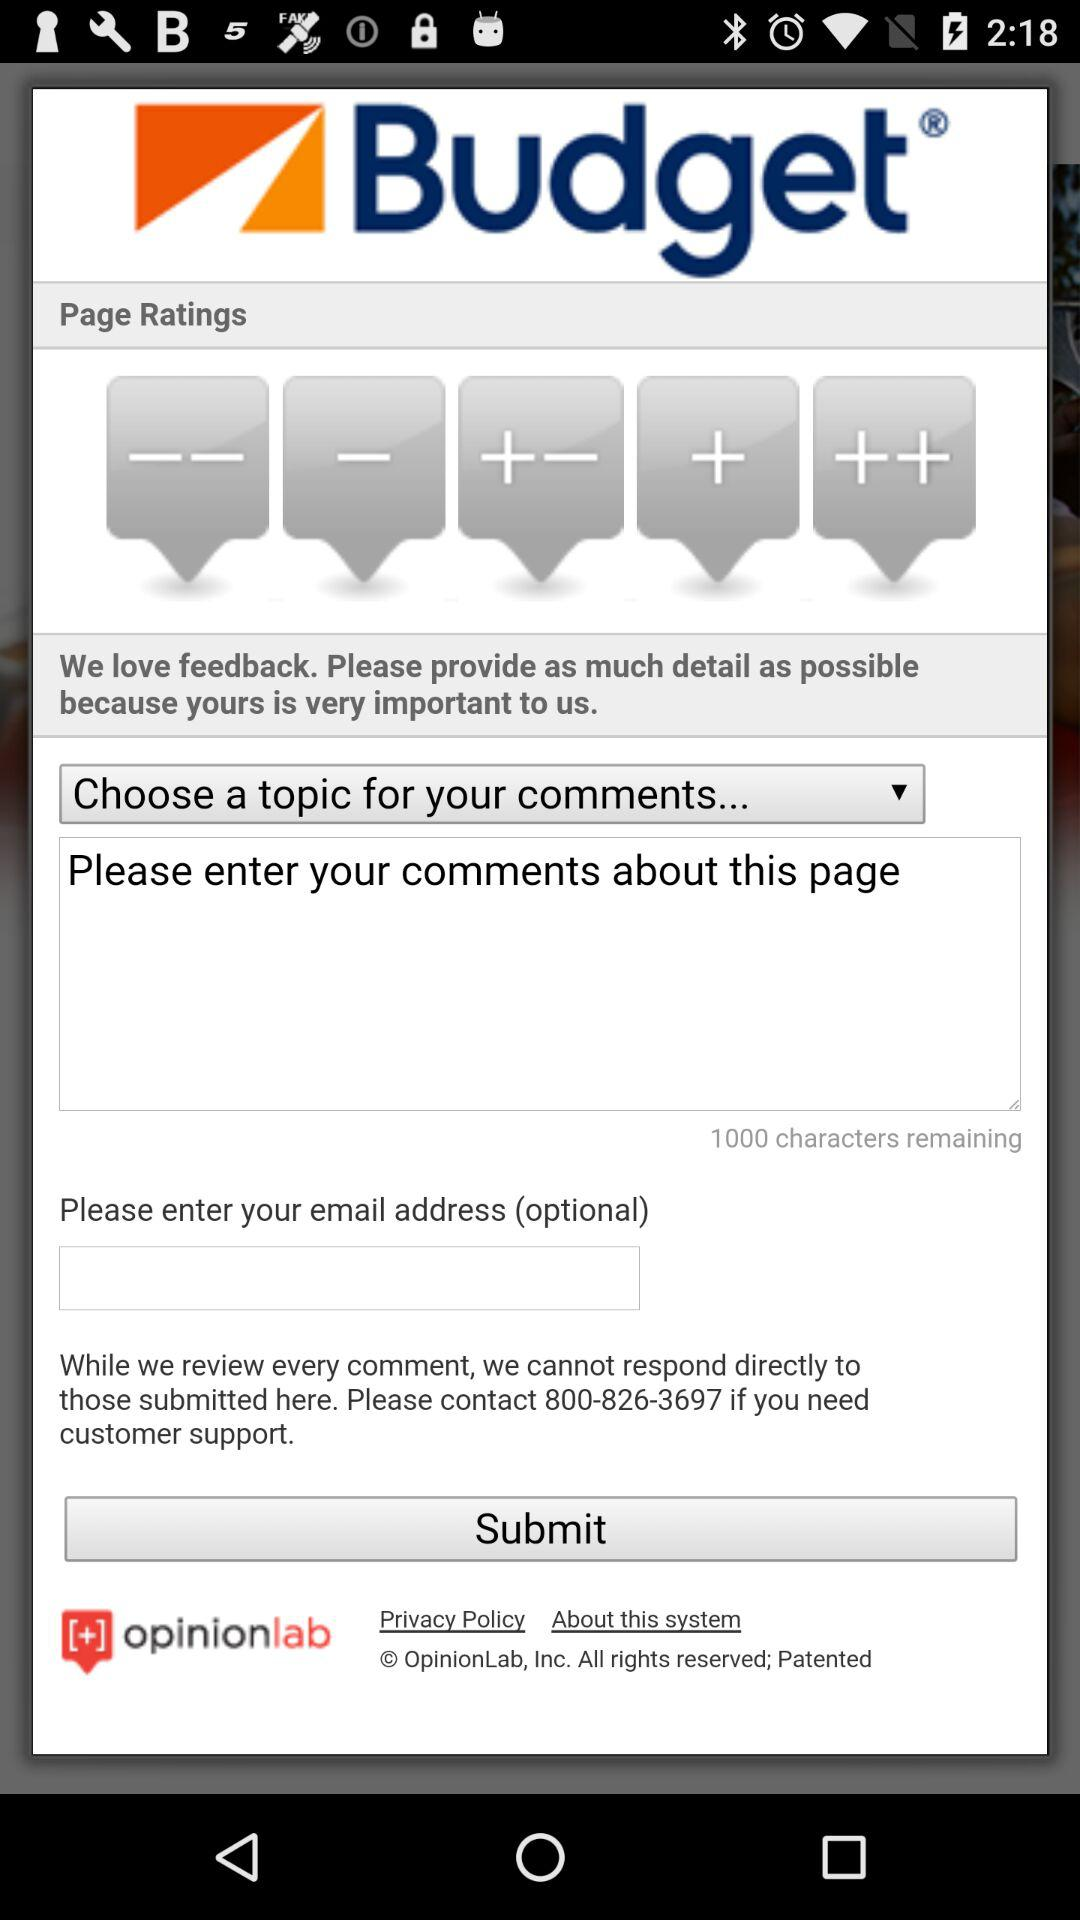What is the application name? The application name is "Budget Car Hire". 